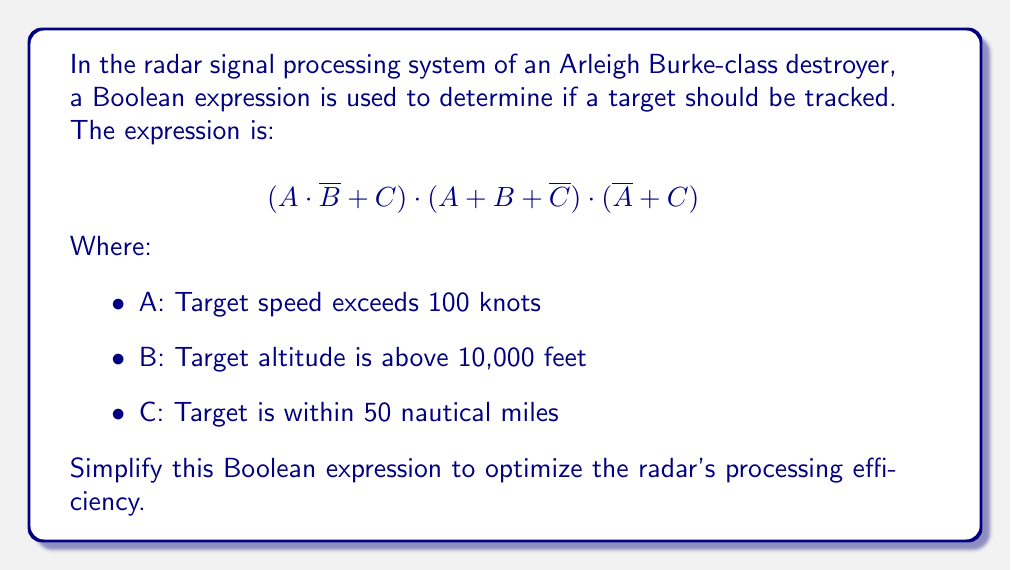Can you answer this question? Let's simplify the expression step by step:

1) First, let's apply the distributive law to the first two terms:
   $$(A \cdot \overline{B} + C) \cdot (A + B + \overline{C})$$
   $$= (A \cdot \overline{B} \cdot A) + (A \cdot \overline{B} \cdot B) + (A \cdot \overline{B} \cdot \overline{C}) + (C \cdot A) + (C \cdot B) + (C \cdot \overline{C})$$

2) Simplify:
   - $A \cdot \overline{B} \cdot A = A \cdot \overline{B}$ (idempotent law)
   - $A \cdot \overline{B} \cdot B = 0$ (complement law)
   - $C \cdot \overline{C} = 0$ (complement law)

3) After simplification:
   $$(A \cdot \overline{B}) + (A \cdot \overline{B} \cdot \overline{C}) + (C \cdot A) + (C \cdot B)$$

4) Factor out $A \cdot \overline{B}$:
   $$A \cdot \overline{B} \cdot (1 + \overline{C}) + (C \cdot A) + (C \cdot B)$$

5) Simplify $(1 + \overline{C}) = 1$:
   $$A \cdot \overline{B} + (C \cdot A) + (C \cdot B)$$

6) Now, let's multiply this result by the third term $(\overline{A} + C)$:
   $$(A \cdot \overline{B} + C \cdot A + C \cdot B) \cdot (\overline{A} + C)$$

7) Distribute:
   $$(A \cdot \overline{B} \cdot \overline{A}) + (A \cdot \overline{B} \cdot C) + (C \cdot A \cdot \overline{A}) + (C \cdot A \cdot C) + (C \cdot B \cdot \overline{A}) + (C \cdot B \cdot C)$$

8) Simplify:
   - $A \cdot \overline{A} = 0$
   - $C \cdot C = C$

9) After simplification:
   $$(A \cdot \overline{B} \cdot C) + (C \cdot A) + (C \cdot B \cdot \overline{A}) + (C \cdot B)$$

10) Factor out C:
    $$C \cdot (A \cdot \overline{B} + A + B \cdot \overline{A} + B)$$

11) Simplify inside the parentheses:
    - $A + B \cdot \overline{A} = A + B$ (absorption law)
    - $A \cdot \overline{B} + A + B = A + B$ (absorption law)

Therefore, the final simplified expression is:
$$C \cdot (A + B)$$
Answer: $$C \cdot (A + B)$$ 